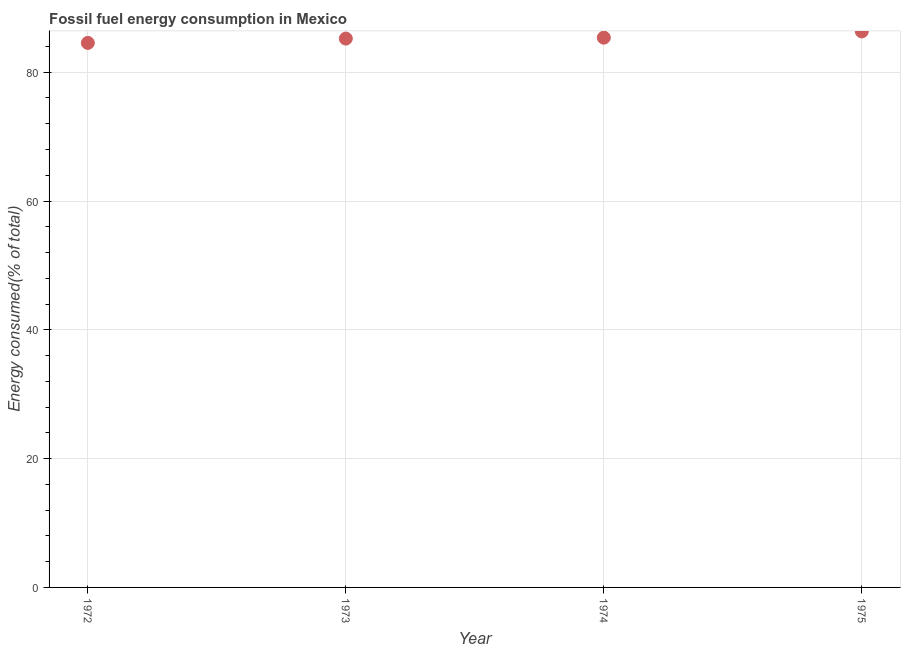What is the fossil fuel energy consumption in 1973?
Keep it short and to the point. 85.22. Across all years, what is the maximum fossil fuel energy consumption?
Offer a terse response. 86.34. Across all years, what is the minimum fossil fuel energy consumption?
Provide a short and direct response. 84.55. In which year was the fossil fuel energy consumption maximum?
Provide a short and direct response. 1975. What is the sum of the fossil fuel energy consumption?
Ensure brevity in your answer.  341.48. What is the difference between the fossil fuel energy consumption in 1973 and 1975?
Keep it short and to the point. -1.12. What is the average fossil fuel energy consumption per year?
Keep it short and to the point. 85.37. What is the median fossil fuel energy consumption?
Keep it short and to the point. 85.3. In how many years, is the fossil fuel energy consumption greater than 20 %?
Give a very brief answer. 4. Do a majority of the years between 1973 and 1974 (inclusive) have fossil fuel energy consumption greater than 36 %?
Provide a short and direct response. Yes. What is the ratio of the fossil fuel energy consumption in 1972 to that in 1973?
Provide a short and direct response. 0.99. Is the difference between the fossil fuel energy consumption in 1972 and 1975 greater than the difference between any two years?
Your response must be concise. Yes. What is the difference between the highest and the second highest fossil fuel energy consumption?
Keep it short and to the point. 0.97. What is the difference between the highest and the lowest fossil fuel energy consumption?
Your answer should be very brief. 1.79. In how many years, is the fossil fuel energy consumption greater than the average fossil fuel energy consumption taken over all years?
Ensure brevity in your answer.  1. How many dotlines are there?
Your answer should be very brief. 1. What is the difference between two consecutive major ticks on the Y-axis?
Offer a very short reply. 20. Are the values on the major ticks of Y-axis written in scientific E-notation?
Keep it short and to the point. No. Does the graph contain any zero values?
Offer a very short reply. No. What is the title of the graph?
Offer a terse response. Fossil fuel energy consumption in Mexico. What is the label or title of the X-axis?
Provide a succinct answer. Year. What is the label or title of the Y-axis?
Make the answer very short. Energy consumed(% of total). What is the Energy consumed(% of total) in 1972?
Give a very brief answer. 84.55. What is the Energy consumed(% of total) in 1973?
Offer a very short reply. 85.22. What is the Energy consumed(% of total) in 1974?
Your answer should be compact. 85.37. What is the Energy consumed(% of total) in 1975?
Offer a very short reply. 86.34. What is the difference between the Energy consumed(% of total) in 1972 and 1973?
Keep it short and to the point. -0.67. What is the difference between the Energy consumed(% of total) in 1972 and 1974?
Make the answer very short. -0.82. What is the difference between the Energy consumed(% of total) in 1972 and 1975?
Your answer should be compact. -1.79. What is the difference between the Energy consumed(% of total) in 1973 and 1974?
Offer a terse response. -0.14. What is the difference between the Energy consumed(% of total) in 1973 and 1975?
Make the answer very short. -1.12. What is the difference between the Energy consumed(% of total) in 1974 and 1975?
Your answer should be compact. -0.97. What is the ratio of the Energy consumed(% of total) in 1972 to that in 1975?
Give a very brief answer. 0.98. What is the ratio of the Energy consumed(% of total) in 1973 to that in 1974?
Your response must be concise. 1. What is the ratio of the Energy consumed(% of total) in 1973 to that in 1975?
Make the answer very short. 0.99. 